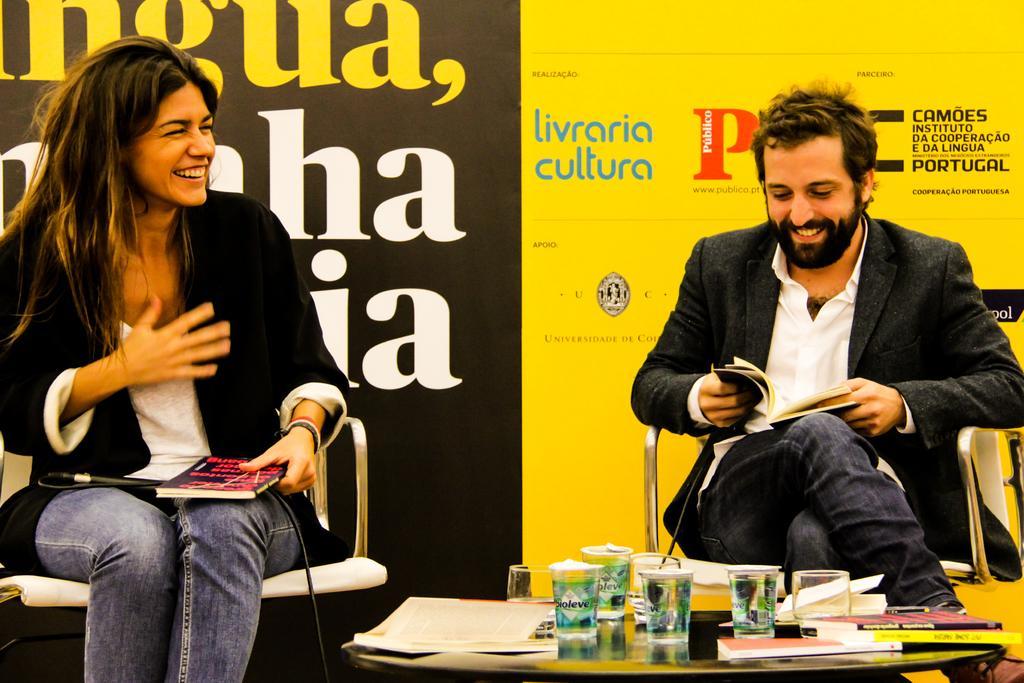Could you give a brief overview of what you see in this image? 2 people are sitting on the chairs. there are holding books in their hands. in front of them there is a table on which there are books and glasses. behind them there is a banner which is yellow and black in color. 